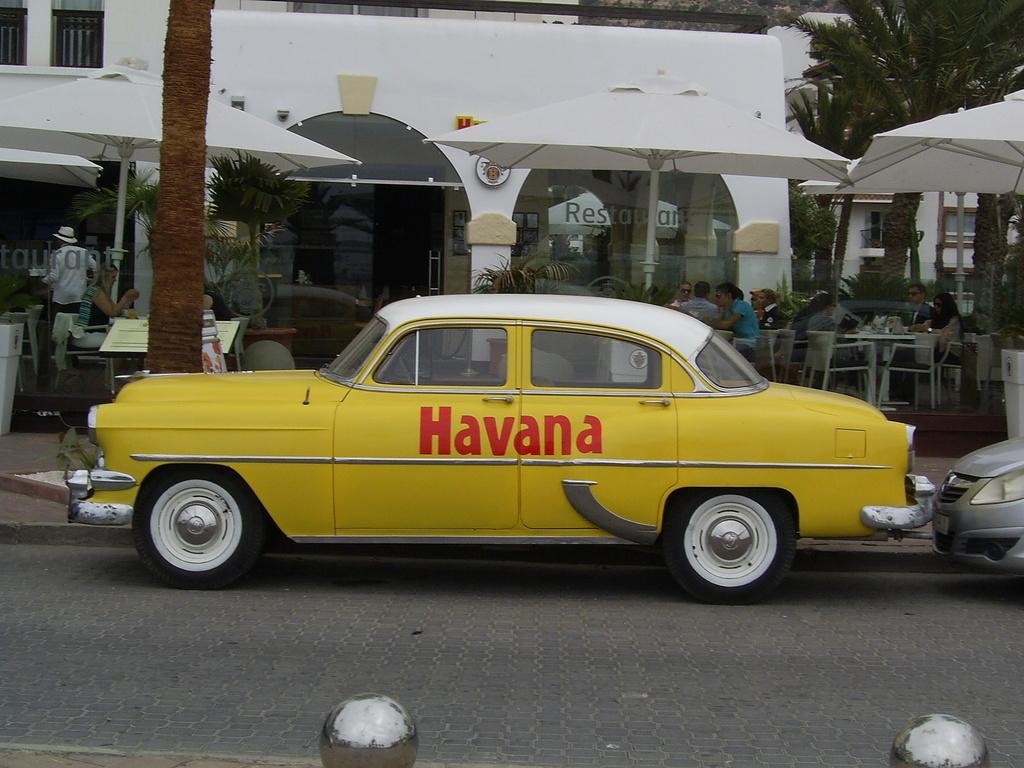<image>
Render a clear and concise summary of the photo. A yellow vintage car that says Havana on it. 